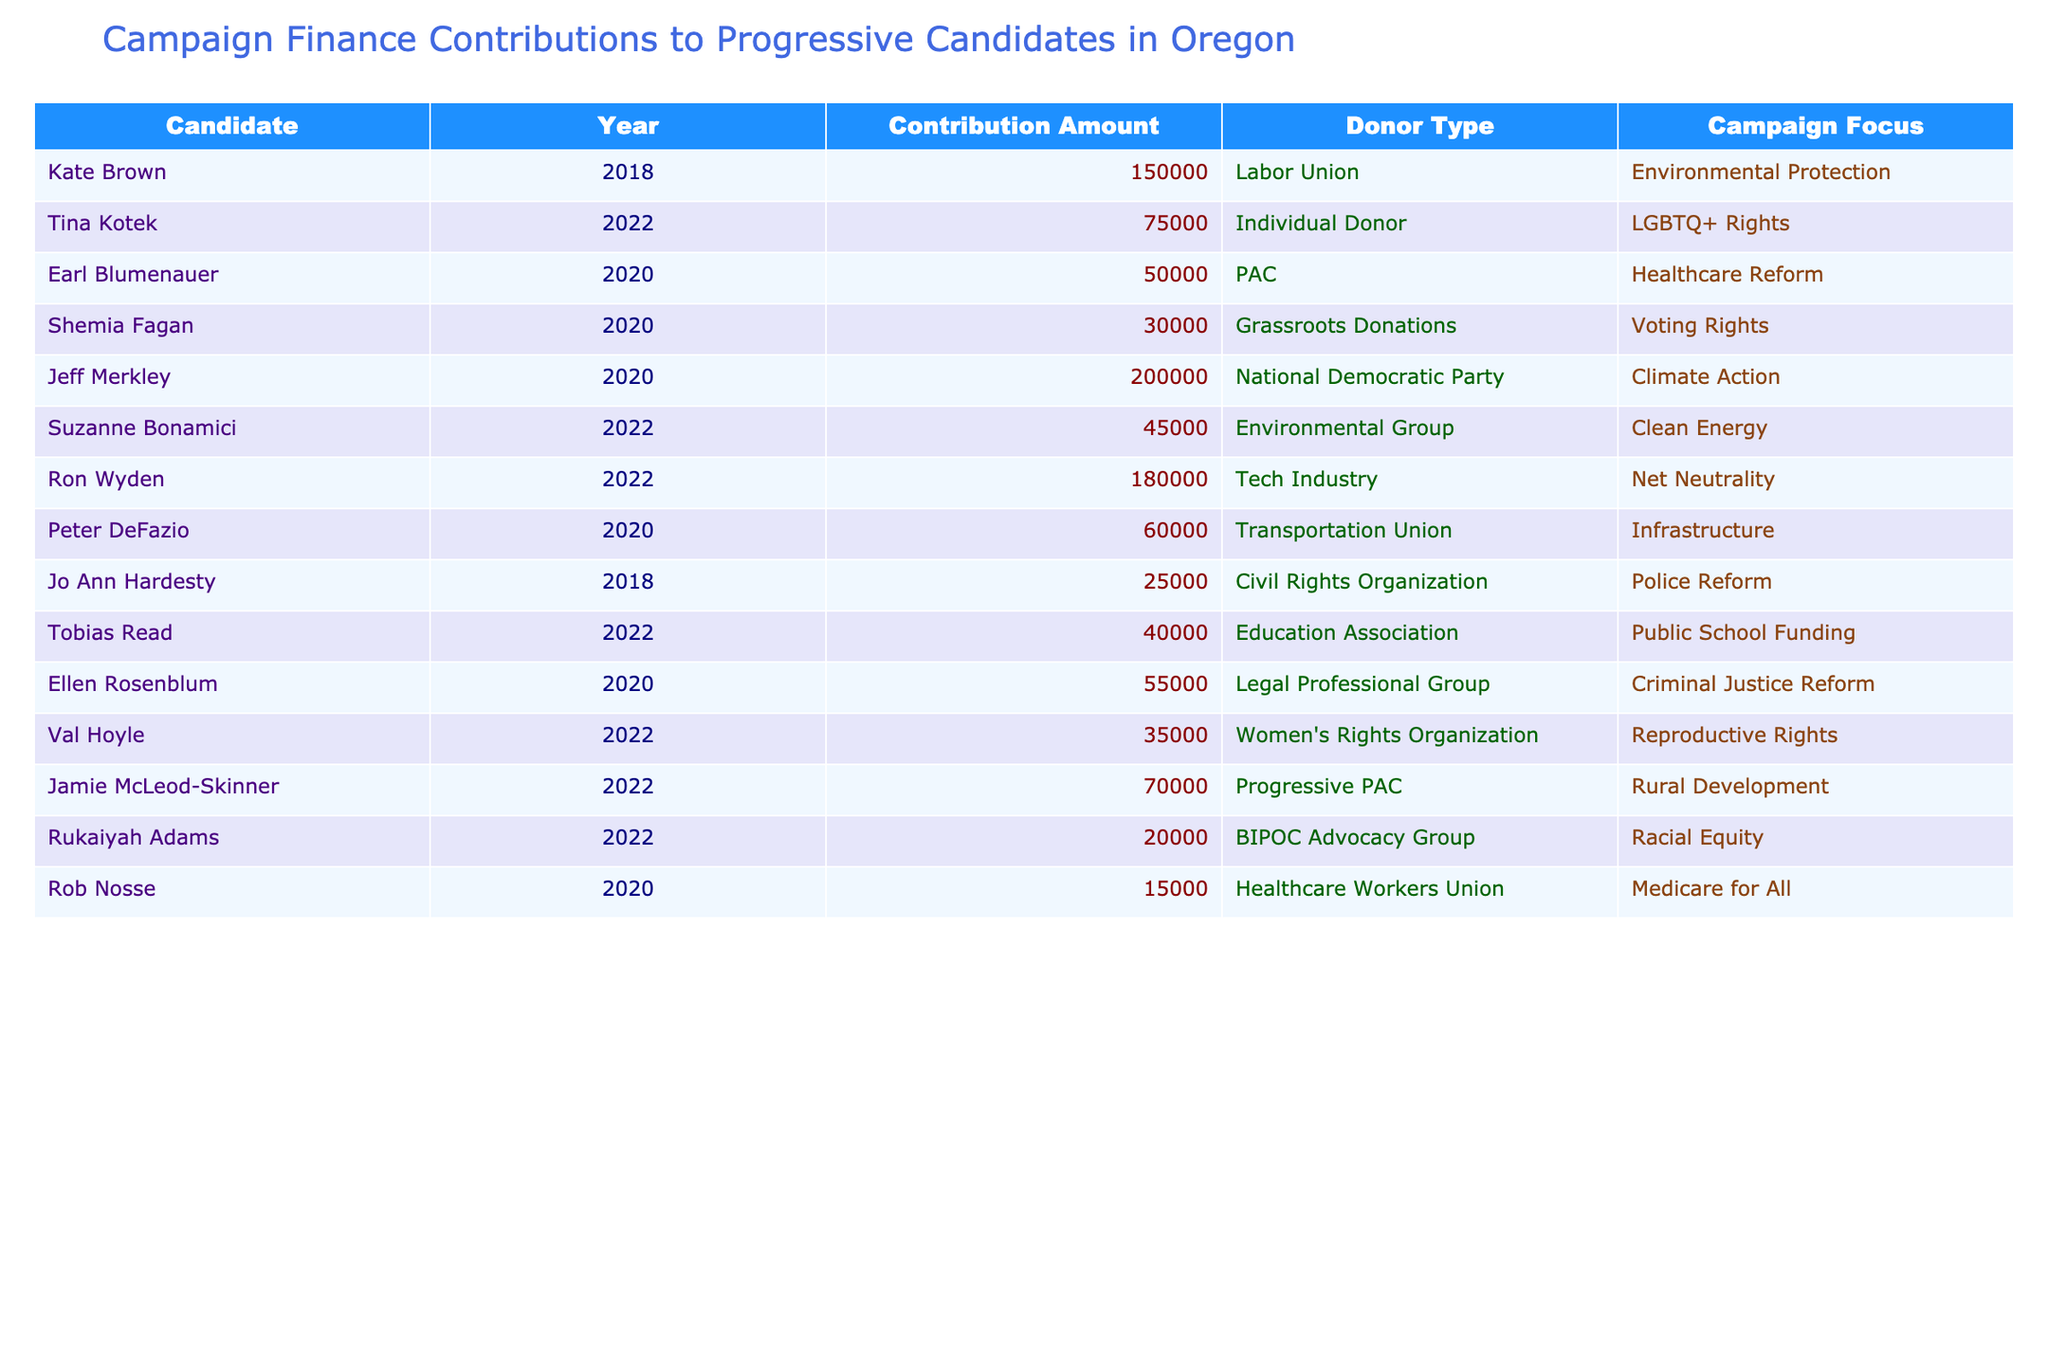What was the total contribution amount made to Ron Wyden in 2022? The table shows that Ron Wyden received a contribution of $180,000 in 2022.
Answer: $180,000 Who received the highest contribution in the year 2020? Comparing the contribution amounts for 2020: Jeff Merkley received $200,000, Earl Blumenauer received $50,000, Shemia Fagan received $30,000, etc. Jeff Merkley has the highest amount at $200,000.
Answer: Jeff Merkley How many candidates received contributions from the Tech Industry? The table lists only Ron Wyden as having received contributions from the Tech Industry.
Answer: 1 What is the average contribution amount to candidates focused on Environmental Protection? The contributions for Environmental Protection are Kate Brown with $150,000 and Jeff Merkley with $200,000. The sum is $350,000, divided by 2 gives an average of $175,000.
Answer: $175,000 Did any candidate receive less than $25,000 in contributions? The table shows that the lowest contribution listed is $15,000 to Rob Nosse, which is less than $25,000.
Answer: Yes Which candidate focused on Racial Equity received a contribution in 2022? The table states that Rukaiyah Adams focused on Racial Equity and received a contribution of $20,000 in 2022.
Answer: Rukaiyah Adams What percentage of the total contributions listed in 2022 was received by Val Hoyle? First, sum the contributions for 2022: Tina Kotek ($75,000) + Ron Wyden ($180,000) + Suzanne Bonamici ($45,000) + Tobias Read ($40,000) + Val Hoyle ($35,000) + Jamie McLeod-Skinner ($70,000) + Rukaiyah Adams ($20,000) = $465,000. Then, Val Hoyle's contribution of $35,000 divided by this total gives about 7.53%.
Answer: 7.53% What was the combined contribution amount received by candidates focused on Climate Action? The table shows that Jeff Merkley (Climate Action) received $200,000. No other candidates listed have a focus on Climate Action, so the total is simply $200,000.
Answer: $200,000 How many individuals or organizations donated more than $50,000 in total? Reviewing contributions over $50,000, we find Kate Brown ($150,000), Jeff Merkley ($200,000), Ron Wyden ($180,000), and Tina Kotek ($75,000). Four candidates received more than $50,000.
Answer: 4 Which candidate has the lowest total contribution listed in the table? Rob Nosse received $15,000, which is the lowest amount in the entire table.
Answer: Rob Nosse 